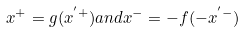Convert formula to latex. <formula><loc_0><loc_0><loc_500><loc_500>x ^ { + } = g ( x ^ { ^ { \prime } + } ) a n d x ^ { - } = - f ( - x ^ { ^ { \prime } - } )</formula> 